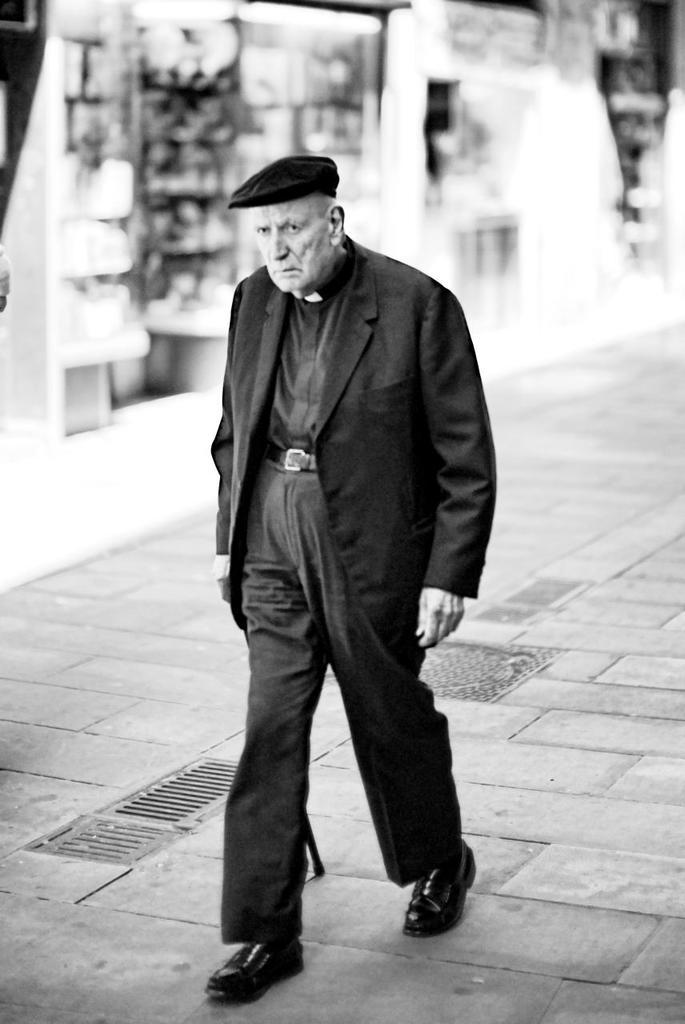What is the main subject of the image? There is a person in the image. What is the person doing in the image? The person is walking. What is the person wearing in the image? The person is wearing a black dress. What is the color scheme of the image? The image is in black and white. What type of shop can be seen in the background of the image? There is no shop visible in the image; it only features a person walking in a black and white setting. 